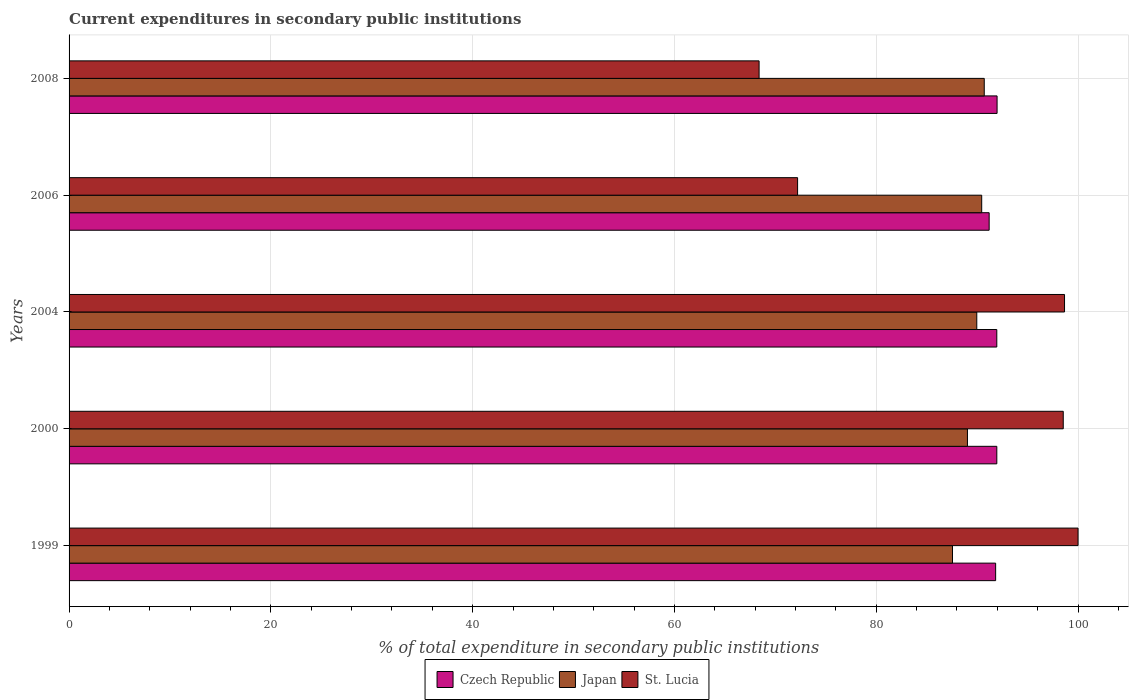How many groups of bars are there?
Provide a succinct answer. 5. How many bars are there on the 1st tick from the top?
Keep it short and to the point. 3. How many bars are there on the 5th tick from the bottom?
Provide a succinct answer. 3. In how many cases, is the number of bars for a given year not equal to the number of legend labels?
Your answer should be compact. 0. Across all years, what is the maximum current expenditures in secondary public institutions in St. Lucia?
Your answer should be compact. 100. Across all years, what is the minimum current expenditures in secondary public institutions in Japan?
Give a very brief answer. 87.56. What is the total current expenditures in secondary public institutions in Czech Republic in the graph?
Your answer should be compact. 458.9. What is the difference between the current expenditures in secondary public institutions in Japan in 2004 and that in 2008?
Make the answer very short. -0.74. What is the difference between the current expenditures in secondary public institutions in Czech Republic in 2006 and the current expenditures in secondary public institutions in Japan in 2008?
Your answer should be compact. 0.49. What is the average current expenditures in secondary public institutions in St. Lucia per year?
Provide a short and direct response. 87.56. In the year 2004, what is the difference between the current expenditures in secondary public institutions in Japan and current expenditures in secondary public institutions in St. Lucia?
Offer a very short reply. -8.7. In how many years, is the current expenditures in secondary public institutions in Japan greater than 28 %?
Offer a terse response. 5. What is the ratio of the current expenditures in secondary public institutions in St. Lucia in 2000 to that in 2006?
Keep it short and to the point. 1.36. Is the difference between the current expenditures in secondary public institutions in Japan in 1999 and 2006 greater than the difference between the current expenditures in secondary public institutions in St. Lucia in 1999 and 2006?
Your answer should be very brief. No. What is the difference between the highest and the second highest current expenditures in secondary public institutions in St. Lucia?
Make the answer very short. 1.34. What is the difference between the highest and the lowest current expenditures in secondary public institutions in Japan?
Make the answer very short. 3.15. In how many years, is the current expenditures in secondary public institutions in Czech Republic greater than the average current expenditures in secondary public institutions in Czech Republic taken over all years?
Provide a short and direct response. 4. What does the 2nd bar from the top in 1999 represents?
Your answer should be very brief. Japan. Is it the case that in every year, the sum of the current expenditures in secondary public institutions in St. Lucia and current expenditures in secondary public institutions in Japan is greater than the current expenditures in secondary public institutions in Czech Republic?
Provide a succinct answer. Yes. How many bars are there?
Ensure brevity in your answer.  15. What is the difference between two consecutive major ticks on the X-axis?
Make the answer very short. 20. Are the values on the major ticks of X-axis written in scientific E-notation?
Your response must be concise. No. Does the graph contain grids?
Offer a very short reply. Yes. Where does the legend appear in the graph?
Offer a terse response. Bottom center. How are the legend labels stacked?
Keep it short and to the point. Horizontal. What is the title of the graph?
Offer a terse response. Current expenditures in secondary public institutions. Does "Brunei Darussalam" appear as one of the legend labels in the graph?
Offer a very short reply. No. What is the label or title of the X-axis?
Offer a very short reply. % of total expenditure in secondary public institutions. What is the % of total expenditure in secondary public institutions in Czech Republic in 1999?
Keep it short and to the point. 91.83. What is the % of total expenditure in secondary public institutions in Japan in 1999?
Your answer should be very brief. 87.56. What is the % of total expenditure in secondary public institutions of Czech Republic in 2000?
Your answer should be compact. 91.95. What is the % of total expenditure in secondary public institutions of Japan in 2000?
Keep it short and to the point. 89.04. What is the % of total expenditure in secondary public institutions of St. Lucia in 2000?
Ensure brevity in your answer.  98.53. What is the % of total expenditure in secondary public institutions of Czech Republic in 2004?
Keep it short and to the point. 91.95. What is the % of total expenditure in secondary public institutions of Japan in 2004?
Give a very brief answer. 89.96. What is the % of total expenditure in secondary public institutions of St. Lucia in 2004?
Ensure brevity in your answer.  98.66. What is the % of total expenditure in secondary public institutions in Czech Republic in 2006?
Offer a very short reply. 91.19. What is the % of total expenditure in secondary public institutions of Japan in 2006?
Your answer should be compact. 90.45. What is the % of total expenditure in secondary public institutions in St. Lucia in 2006?
Give a very brief answer. 72.2. What is the % of total expenditure in secondary public institutions of Czech Republic in 2008?
Keep it short and to the point. 91.98. What is the % of total expenditure in secondary public institutions of Japan in 2008?
Your answer should be very brief. 90.7. What is the % of total expenditure in secondary public institutions in St. Lucia in 2008?
Your answer should be very brief. 68.39. Across all years, what is the maximum % of total expenditure in secondary public institutions in Czech Republic?
Offer a very short reply. 91.98. Across all years, what is the maximum % of total expenditure in secondary public institutions of Japan?
Your answer should be very brief. 90.7. Across all years, what is the minimum % of total expenditure in secondary public institutions of Czech Republic?
Provide a succinct answer. 91.19. Across all years, what is the minimum % of total expenditure in secondary public institutions in Japan?
Give a very brief answer. 87.56. Across all years, what is the minimum % of total expenditure in secondary public institutions in St. Lucia?
Offer a terse response. 68.39. What is the total % of total expenditure in secondary public institutions of Czech Republic in the graph?
Give a very brief answer. 458.9. What is the total % of total expenditure in secondary public institutions in Japan in the graph?
Ensure brevity in your answer.  447.72. What is the total % of total expenditure in secondary public institutions in St. Lucia in the graph?
Provide a succinct answer. 437.79. What is the difference between the % of total expenditure in secondary public institutions in Czech Republic in 1999 and that in 2000?
Your response must be concise. -0.12. What is the difference between the % of total expenditure in secondary public institutions in Japan in 1999 and that in 2000?
Provide a succinct answer. -1.48. What is the difference between the % of total expenditure in secondary public institutions in St. Lucia in 1999 and that in 2000?
Provide a succinct answer. 1.47. What is the difference between the % of total expenditure in secondary public institutions in Czech Republic in 1999 and that in 2004?
Offer a very short reply. -0.11. What is the difference between the % of total expenditure in secondary public institutions of Japan in 1999 and that in 2004?
Ensure brevity in your answer.  -2.41. What is the difference between the % of total expenditure in secondary public institutions in St. Lucia in 1999 and that in 2004?
Give a very brief answer. 1.34. What is the difference between the % of total expenditure in secondary public institutions of Czech Republic in 1999 and that in 2006?
Offer a very short reply. 0.64. What is the difference between the % of total expenditure in secondary public institutions of Japan in 1999 and that in 2006?
Offer a very short reply. -2.89. What is the difference between the % of total expenditure in secondary public institutions in St. Lucia in 1999 and that in 2006?
Provide a succinct answer. 27.8. What is the difference between the % of total expenditure in secondary public institutions of Czech Republic in 1999 and that in 2008?
Provide a short and direct response. -0.14. What is the difference between the % of total expenditure in secondary public institutions of Japan in 1999 and that in 2008?
Provide a short and direct response. -3.15. What is the difference between the % of total expenditure in secondary public institutions in St. Lucia in 1999 and that in 2008?
Offer a very short reply. 31.61. What is the difference between the % of total expenditure in secondary public institutions in Czech Republic in 2000 and that in 2004?
Make the answer very short. 0. What is the difference between the % of total expenditure in secondary public institutions in Japan in 2000 and that in 2004?
Give a very brief answer. -0.92. What is the difference between the % of total expenditure in secondary public institutions in St. Lucia in 2000 and that in 2004?
Offer a terse response. -0.13. What is the difference between the % of total expenditure in secondary public institutions in Czech Republic in 2000 and that in 2006?
Your answer should be compact. 0.76. What is the difference between the % of total expenditure in secondary public institutions of Japan in 2000 and that in 2006?
Give a very brief answer. -1.41. What is the difference between the % of total expenditure in secondary public institutions of St. Lucia in 2000 and that in 2006?
Your answer should be compact. 26.33. What is the difference between the % of total expenditure in secondary public institutions in Czech Republic in 2000 and that in 2008?
Provide a short and direct response. -0.03. What is the difference between the % of total expenditure in secondary public institutions in Japan in 2000 and that in 2008?
Your answer should be very brief. -1.67. What is the difference between the % of total expenditure in secondary public institutions in St. Lucia in 2000 and that in 2008?
Give a very brief answer. 30.14. What is the difference between the % of total expenditure in secondary public institutions of Czech Republic in 2004 and that in 2006?
Your response must be concise. 0.76. What is the difference between the % of total expenditure in secondary public institutions in Japan in 2004 and that in 2006?
Your answer should be compact. -0.49. What is the difference between the % of total expenditure in secondary public institutions of St. Lucia in 2004 and that in 2006?
Keep it short and to the point. 26.46. What is the difference between the % of total expenditure in secondary public institutions of Czech Republic in 2004 and that in 2008?
Offer a terse response. -0.03. What is the difference between the % of total expenditure in secondary public institutions of Japan in 2004 and that in 2008?
Keep it short and to the point. -0.74. What is the difference between the % of total expenditure in secondary public institutions in St. Lucia in 2004 and that in 2008?
Offer a very short reply. 30.27. What is the difference between the % of total expenditure in secondary public institutions in Czech Republic in 2006 and that in 2008?
Your answer should be very brief. -0.79. What is the difference between the % of total expenditure in secondary public institutions in Japan in 2006 and that in 2008?
Keep it short and to the point. -0.25. What is the difference between the % of total expenditure in secondary public institutions in St. Lucia in 2006 and that in 2008?
Make the answer very short. 3.82. What is the difference between the % of total expenditure in secondary public institutions in Czech Republic in 1999 and the % of total expenditure in secondary public institutions in Japan in 2000?
Make the answer very short. 2.79. What is the difference between the % of total expenditure in secondary public institutions of Czech Republic in 1999 and the % of total expenditure in secondary public institutions of St. Lucia in 2000?
Keep it short and to the point. -6.7. What is the difference between the % of total expenditure in secondary public institutions of Japan in 1999 and the % of total expenditure in secondary public institutions of St. Lucia in 2000?
Your response must be concise. -10.98. What is the difference between the % of total expenditure in secondary public institutions in Czech Republic in 1999 and the % of total expenditure in secondary public institutions in Japan in 2004?
Ensure brevity in your answer.  1.87. What is the difference between the % of total expenditure in secondary public institutions in Czech Republic in 1999 and the % of total expenditure in secondary public institutions in St. Lucia in 2004?
Your answer should be very brief. -6.83. What is the difference between the % of total expenditure in secondary public institutions of Japan in 1999 and the % of total expenditure in secondary public institutions of St. Lucia in 2004?
Keep it short and to the point. -11.1. What is the difference between the % of total expenditure in secondary public institutions of Czech Republic in 1999 and the % of total expenditure in secondary public institutions of Japan in 2006?
Give a very brief answer. 1.38. What is the difference between the % of total expenditure in secondary public institutions in Czech Republic in 1999 and the % of total expenditure in secondary public institutions in St. Lucia in 2006?
Offer a terse response. 19.63. What is the difference between the % of total expenditure in secondary public institutions of Japan in 1999 and the % of total expenditure in secondary public institutions of St. Lucia in 2006?
Your answer should be compact. 15.35. What is the difference between the % of total expenditure in secondary public institutions in Czech Republic in 1999 and the % of total expenditure in secondary public institutions in Japan in 2008?
Offer a very short reply. 1.13. What is the difference between the % of total expenditure in secondary public institutions in Czech Republic in 1999 and the % of total expenditure in secondary public institutions in St. Lucia in 2008?
Offer a very short reply. 23.44. What is the difference between the % of total expenditure in secondary public institutions in Japan in 1999 and the % of total expenditure in secondary public institutions in St. Lucia in 2008?
Your response must be concise. 19.17. What is the difference between the % of total expenditure in secondary public institutions in Czech Republic in 2000 and the % of total expenditure in secondary public institutions in Japan in 2004?
Provide a succinct answer. 1.99. What is the difference between the % of total expenditure in secondary public institutions in Czech Republic in 2000 and the % of total expenditure in secondary public institutions in St. Lucia in 2004?
Offer a very short reply. -6.71. What is the difference between the % of total expenditure in secondary public institutions of Japan in 2000 and the % of total expenditure in secondary public institutions of St. Lucia in 2004?
Offer a very short reply. -9.62. What is the difference between the % of total expenditure in secondary public institutions in Czech Republic in 2000 and the % of total expenditure in secondary public institutions in Japan in 2006?
Your answer should be very brief. 1.5. What is the difference between the % of total expenditure in secondary public institutions in Czech Republic in 2000 and the % of total expenditure in secondary public institutions in St. Lucia in 2006?
Provide a short and direct response. 19.74. What is the difference between the % of total expenditure in secondary public institutions of Japan in 2000 and the % of total expenditure in secondary public institutions of St. Lucia in 2006?
Provide a short and direct response. 16.83. What is the difference between the % of total expenditure in secondary public institutions of Czech Republic in 2000 and the % of total expenditure in secondary public institutions of Japan in 2008?
Provide a short and direct response. 1.25. What is the difference between the % of total expenditure in secondary public institutions of Czech Republic in 2000 and the % of total expenditure in secondary public institutions of St. Lucia in 2008?
Your answer should be compact. 23.56. What is the difference between the % of total expenditure in secondary public institutions of Japan in 2000 and the % of total expenditure in secondary public institutions of St. Lucia in 2008?
Provide a short and direct response. 20.65. What is the difference between the % of total expenditure in secondary public institutions of Czech Republic in 2004 and the % of total expenditure in secondary public institutions of Japan in 2006?
Give a very brief answer. 1.5. What is the difference between the % of total expenditure in secondary public institutions of Czech Republic in 2004 and the % of total expenditure in secondary public institutions of St. Lucia in 2006?
Ensure brevity in your answer.  19.74. What is the difference between the % of total expenditure in secondary public institutions of Japan in 2004 and the % of total expenditure in secondary public institutions of St. Lucia in 2006?
Offer a very short reply. 17.76. What is the difference between the % of total expenditure in secondary public institutions in Czech Republic in 2004 and the % of total expenditure in secondary public institutions in Japan in 2008?
Provide a short and direct response. 1.24. What is the difference between the % of total expenditure in secondary public institutions in Czech Republic in 2004 and the % of total expenditure in secondary public institutions in St. Lucia in 2008?
Your response must be concise. 23.56. What is the difference between the % of total expenditure in secondary public institutions of Japan in 2004 and the % of total expenditure in secondary public institutions of St. Lucia in 2008?
Ensure brevity in your answer.  21.57. What is the difference between the % of total expenditure in secondary public institutions in Czech Republic in 2006 and the % of total expenditure in secondary public institutions in Japan in 2008?
Provide a short and direct response. 0.49. What is the difference between the % of total expenditure in secondary public institutions of Czech Republic in 2006 and the % of total expenditure in secondary public institutions of St. Lucia in 2008?
Your answer should be compact. 22.8. What is the difference between the % of total expenditure in secondary public institutions in Japan in 2006 and the % of total expenditure in secondary public institutions in St. Lucia in 2008?
Your answer should be very brief. 22.06. What is the average % of total expenditure in secondary public institutions of Czech Republic per year?
Offer a very short reply. 91.78. What is the average % of total expenditure in secondary public institutions in Japan per year?
Offer a very short reply. 89.54. What is the average % of total expenditure in secondary public institutions in St. Lucia per year?
Provide a short and direct response. 87.56. In the year 1999, what is the difference between the % of total expenditure in secondary public institutions of Czech Republic and % of total expenditure in secondary public institutions of Japan?
Make the answer very short. 4.28. In the year 1999, what is the difference between the % of total expenditure in secondary public institutions of Czech Republic and % of total expenditure in secondary public institutions of St. Lucia?
Your answer should be compact. -8.17. In the year 1999, what is the difference between the % of total expenditure in secondary public institutions in Japan and % of total expenditure in secondary public institutions in St. Lucia?
Give a very brief answer. -12.44. In the year 2000, what is the difference between the % of total expenditure in secondary public institutions in Czech Republic and % of total expenditure in secondary public institutions in Japan?
Your answer should be very brief. 2.91. In the year 2000, what is the difference between the % of total expenditure in secondary public institutions in Czech Republic and % of total expenditure in secondary public institutions in St. Lucia?
Your answer should be very brief. -6.58. In the year 2000, what is the difference between the % of total expenditure in secondary public institutions in Japan and % of total expenditure in secondary public institutions in St. Lucia?
Make the answer very short. -9.49. In the year 2004, what is the difference between the % of total expenditure in secondary public institutions of Czech Republic and % of total expenditure in secondary public institutions of Japan?
Provide a short and direct response. 1.98. In the year 2004, what is the difference between the % of total expenditure in secondary public institutions of Czech Republic and % of total expenditure in secondary public institutions of St. Lucia?
Offer a very short reply. -6.71. In the year 2004, what is the difference between the % of total expenditure in secondary public institutions of Japan and % of total expenditure in secondary public institutions of St. Lucia?
Make the answer very short. -8.7. In the year 2006, what is the difference between the % of total expenditure in secondary public institutions of Czech Republic and % of total expenditure in secondary public institutions of Japan?
Give a very brief answer. 0.74. In the year 2006, what is the difference between the % of total expenditure in secondary public institutions of Czech Republic and % of total expenditure in secondary public institutions of St. Lucia?
Your answer should be very brief. 18.99. In the year 2006, what is the difference between the % of total expenditure in secondary public institutions in Japan and % of total expenditure in secondary public institutions in St. Lucia?
Your response must be concise. 18.25. In the year 2008, what is the difference between the % of total expenditure in secondary public institutions in Czech Republic and % of total expenditure in secondary public institutions in Japan?
Provide a succinct answer. 1.27. In the year 2008, what is the difference between the % of total expenditure in secondary public institutions in Czech Republic and % of total expenditure in secondary public institutions in St. Lucia?
Ensure brevity in your answer.  23.59. In the year 2008, what is the difference between the % of total expenditure in secondary public institutions of Japan and % of total expenditure in secondary public institutions of St. Lucia?
Offer a very short reply. 22.32. What is the ratio of the % of total expenditure in secondary public institutions in Japan in 1999 to that in 2000?
Provide a short and direct response. 0.98. What is the ratio of the % of total expenditure in secondary public institutions of St. Lucia in 1999 to that in 2000?
Offer a very short reply. 1.01. What is the ratio of the % of total expenditure in secondary public institutions in Czech Republic in 1999 to that in 2004?
Offer a very short reply. 1. What is the ratio of the % of total expenditure in secondary public institutions in Japan in 1999 to that in 2004?
Make the answer very short. 0.97. What is the ratio of the % of total expenditure in secondary public institutions in St. Lucia in 1999 to that in 2004?
Offer a terse response. 1.01. What is the ratio of the % of total expenditure in secondary public institutions in Czech Republic in 1999 to that in 2006?
Your response must be concise. 1.01. What is the ratio of the % of total expenditure in secondary public institutions in St. Lucia in 1999 to that in 2006?
Offer a terse response. 1.39. What is the ratio of the % of total expenditure in secondary public institutions in Japan in 1999 to that in 2008?
Your response must be concise. 0.97. What is the ratio of the % of total expenditure in secondary public institutions in St. Lucia in 1999 to that in 2008?
Offer a terse response. 1.46. What is the ratio of the % of total expenditure in secondary public institutions in Czech Republic in 2000 to that in 2006?
Your answer should be very brief. 1.01. What is the ratio of the % of total expenditure in secondary public institutions in Japan in 2000 to that in 2006?
Make the answer very short. 0.98. What is the ratio of the % of total expenditure in secondary public institutions in St. Lucia in 2000 to that in 2006?
Your answer should be compact. 1.36. What is the ratio of the % of total expenditure in secondary public institutions in Japan in 2000 to that in 2008?
Provide a short and direct response. 0.98. What is the ratio of the % of total expenditure in secondary public institutions of St. Lucia in 2000 to that in 2008?
Your response must be concise. 1.44. What is the ratio of the % of total expenditure in secondary public institutions in Czech Republic in 2004 to that in 2006?
Ensure brevity in your answer.  1.01. What is the ratio of the % of total expenditure in secondary public institutions in Japan in 2004 to that in 2006?
Keep it short and to the point. 0.99. What is the ratio of the % of total expenditure in secondary public institutions in St. Lucia in 2004 to that in 2006?
Your answer should be very brief. 1.37. What is the ratio of the % of total expenditure in secondary public institutions of Japan in 2004 to that in 2008?
Your answer should be very brief. 0.99. What is the ratio of the % of total expenditure in secondary public institutions in St. Lucia in 2004 to that in 2008?
Make the answer very short. 1.44. What is the ratio of the % of total expenditure in secondary public institutions of St. Lucia in 2006 to that in 2008?
Your response must be concise. 1.06. What is the difference between the highest and the second highest % of total expenditure in secondary public institutions in Czech Republic?
Offer a very short reply. 0.03. What is the difference between the highest and the second highest % of total expenditure in secondary public institutions in Japan?
Ensure brevity in your answer.  0.25. What is the difference between the highest and the second highest % of total expenditure in secondary public institutions in St. Lucia?
Ensure brevity in your answer.  1.34. What is the difference between the highest and the lowest % of total expenditure in secondary public institutions in Czech Republic?
Your answer should be compact. 0.79. What is the difference between the highest and the lowest % of total expenditure in secondary public institutions of Japan?
Provide a succinct answer. 3.15. What is the difference between the highest and the lowest % of total expenditure in secondary public institutions in St. Lucia?
Give a very brief answer. 31.61. 